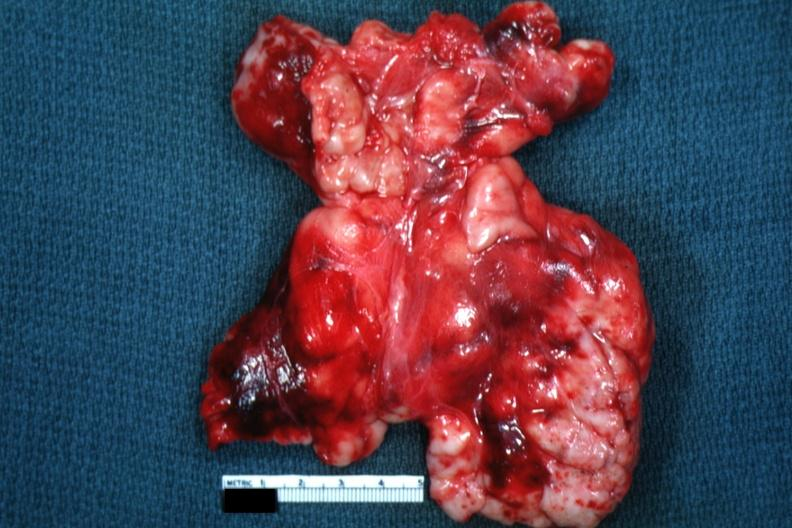s jejunum present?
Answer the question using a single word or phrase. No 